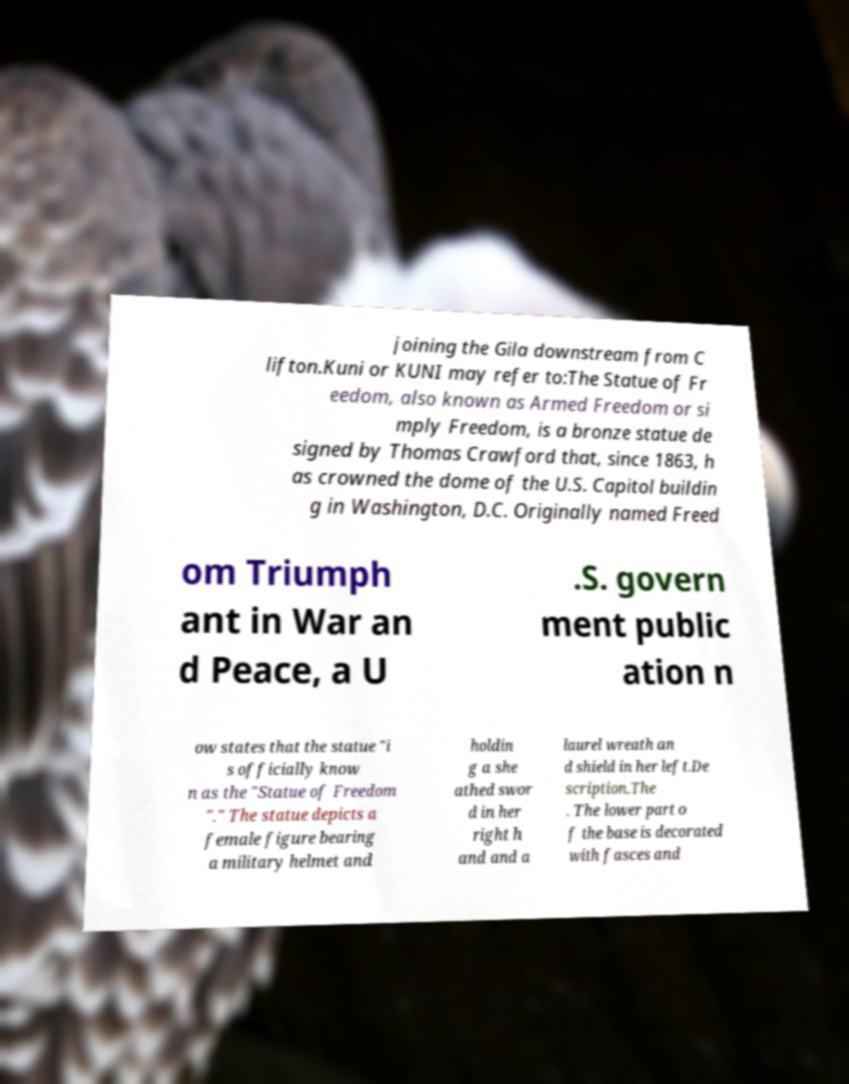For documentation purposes, I need the text within this image transcribed. Could you provide that? joining the Gila downstream from C lifton.Kuni or KUNI may refer to:The Statue of Fr eedom, also known as Armed Freedom or si mply Freedom, is a bronze statue de signed by Thomas Crawford that, since 1863, h as crowned the dome of the U.S. Capitol buildin g in Washington, D.C. Originally named Freed om Triumph ant in War an d Peace, a U .S. govern ment public ation n ow states that the statue "i s officially know n as the "Statue of Freedom "." The statue depicts a female figure bearing a military helmet and holdin g a she athed swor d in her right h and and a laurel wreath an d shield in her left.De scription.The . The lower part o f the base is decorated with fasces and 